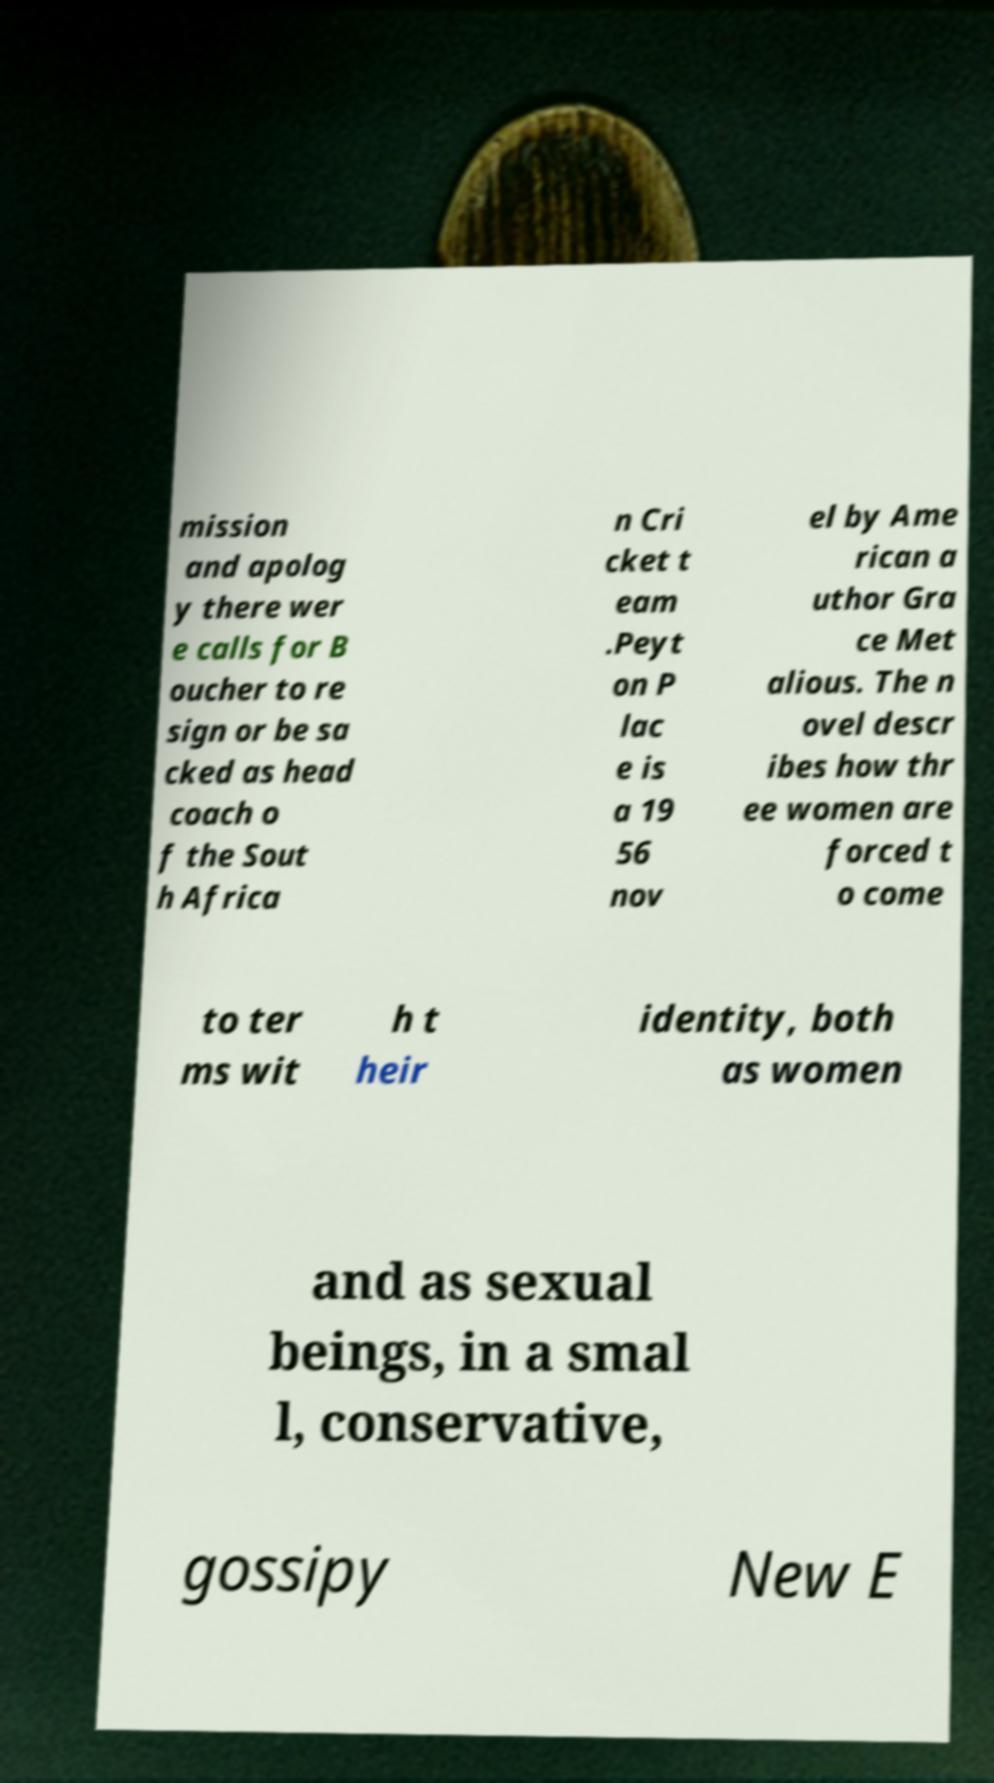There's text embedded in this image that I need extracted. Can you transcribe it verbatim? mission and apolog y there wer e calls for B oucher to re sign or be sa cked as head coach o f the Sout h Africa n Cri cket t eam .Peyt on P lac e is a 19 56 nov el by Ame rican a uthor Gra ce Met alious. The n ovel descr ibes how thr ee women are forced t o come to ter ms wit h t heir identity, both as women and as sexual beings, in a smal l, conservative, gossipy New E 